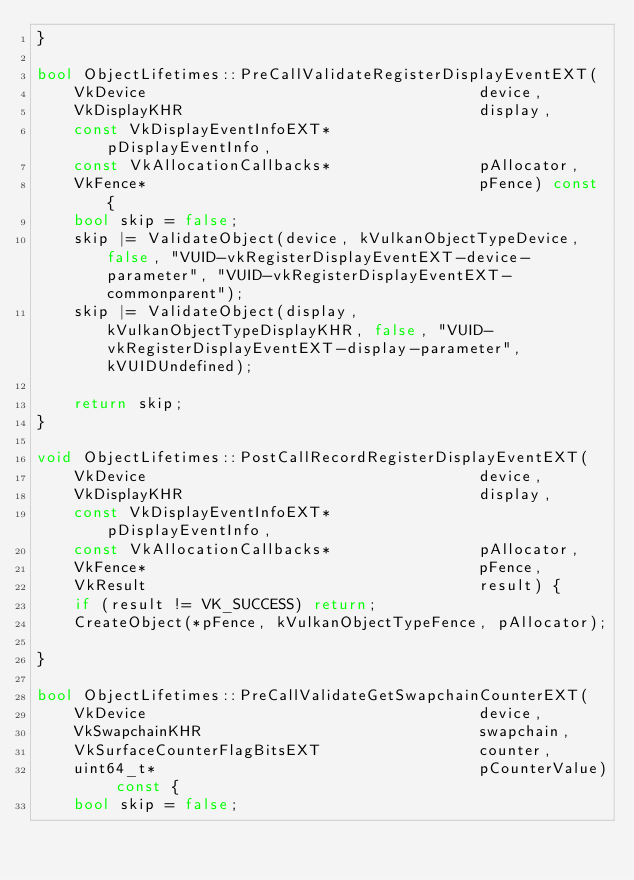<code> <loc_0><loc_0><loc_500><loc_500><_C++_>}

bool ObjectLifetimes::PreCallValidateRegisterDisplayEventEXT(
    VkDevice                                    device,
    VkDisplayKHR                                display,
    const VkDisplayEventInfoEXT*                pDisplayEventInfo,
    const VkAllocationCallbacks*                pAllocator,
    VkFence*                                    pFence) const {
    bool skip = false;
    skip |= ValidateObject(device, kVulkanObjectTypeDevice, false, "VUID-vkRegisterDisplayEventEXT-device-parameter", "VUID-vkRegisterDisplayEventEXT-commonparent");
    skip |= ValidateObject(display, kVulkanObjectTypeDisplayKHR, false, "VUID-vkRegisterDisplayEventEXT-display-parameter", kVUIDUndefined);

    return skip;
}

void ObjectLifetimes::PostCallRecordRegisterDisplayEventEXT(
    VkDevice                                    device,
    VkDisplayKHR                                display,
    const VkDisplayEventInfoEXT*                pDisplayEventInfo,
    const VkAllocationCallbacks*                pAllocator,
    VkFence*                                    pFence,
    VkResult                                    result) {
    if (result != VK_SUCCESS) return;
    CreateObject(*pFence, kVulkanObjectTypeFence, pAllocator);

}

bool ObjectLifetimes::PreCallValidateGetSwapchainCounterEXT(
    VkDevice                                    device,
    VkSwapchainKHR                              swapchain,
    VkSurfaceCounterFlagBitsEXT                 counter,
    uint64_t*                                   pCounterValue) const {
    bool skip = false;</code> 